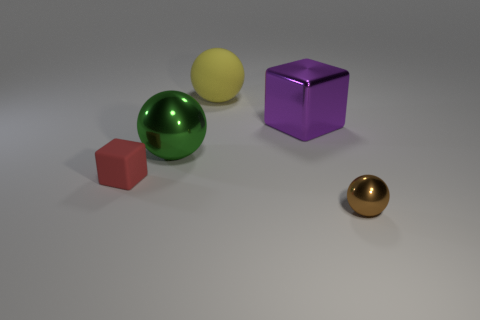Add 2 big yellow rubber objects. How many objects exist? 7 Subtract all blocks. How many objects are left? 3 Subtract 0 cyan balls. How many objects are left? 5 Subtract all small gray metallic blocks. Subtract all tiny balls. How many objects are left? 4 Add 1 big rubber balls. How many big rubber balls are left? 2 Add 2 brown metal objects. How many brown metal objects exist? 3 